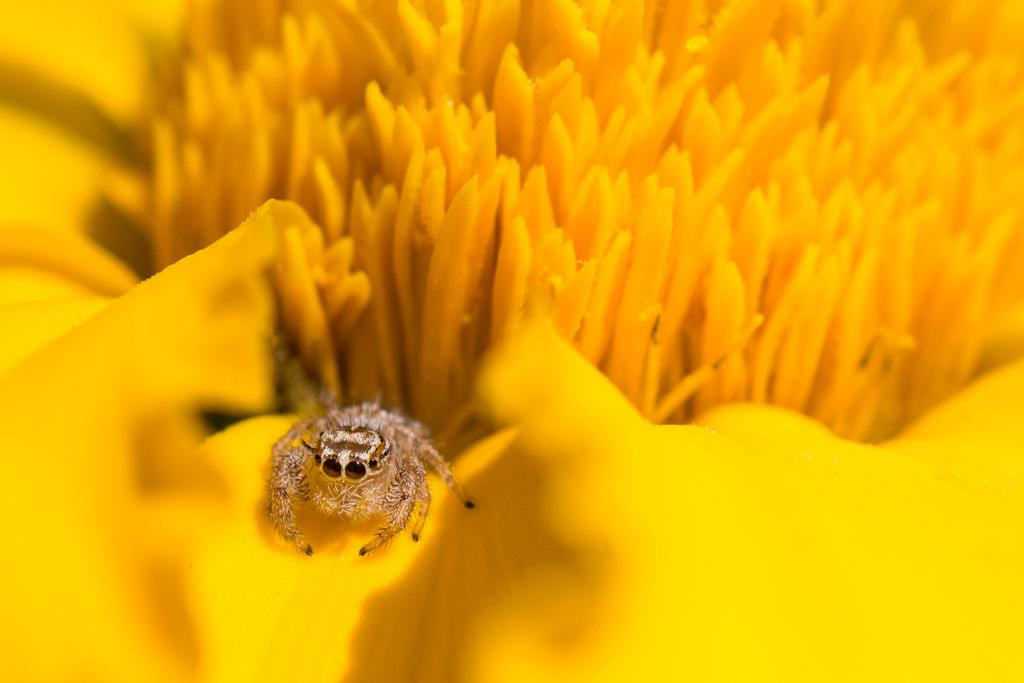What is present in the image? There is an insect in the image. Where is the insect located? The insect is on a yellow flower. What type of van can be seen in the image? There is no van present in the image; it features an insect on a yellow flower. What meal is being prepared in the image? There is no meal preparation visible in the image; it only shows an insect on a yellow flower. 